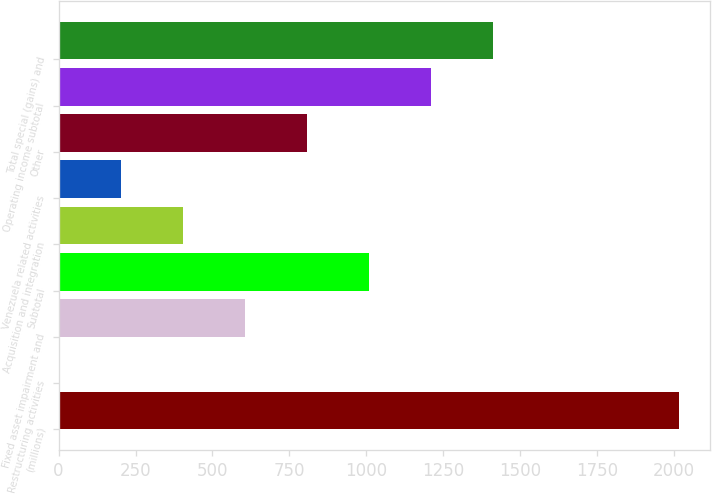Convert chart to OTSL. <chart><loc_0><loc_0><loc_500><loc_500><bar_chart><fcel>(millions)<fcel>Restructuring activities<fcel>Fixed asset impairment and<fcel>Subtotal<fcel>Acquisition and integration<fcel>Venezuela related activities<fcel>Other<fcel>Operating income subtotal<fcel>Total special (gains) and<nl><fcel>2016<fcel>0.4<fcel>605.08<fcel>1008.2<fcel>403.52<fcel>201.96<fcel>806.64<fcel>1209.76<fcel>1411.32<nl></chart> 